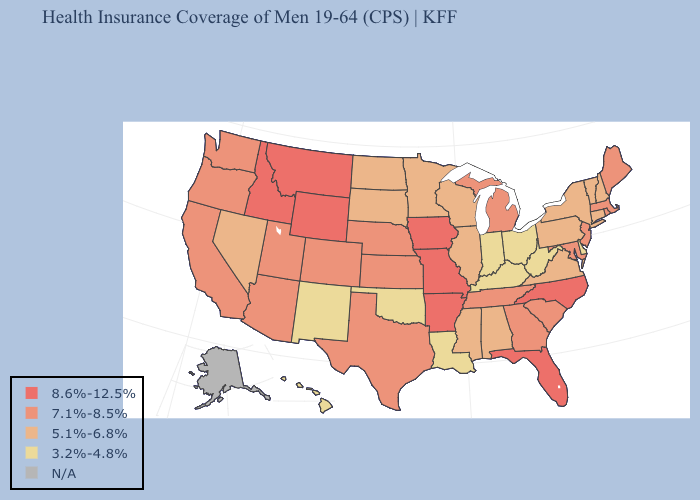What is the lowest value in the USA?
Concise answer only. 3.2%-4.8%. Name the states that have a value in the range 8.6%-12.5%?
Keep it brief. Arkansas, Florida, Idaho, Iowa, Missouri, Montana, North Carolina, Wyoming. Name the states that have a value in the range 3.2%-4.8%?
Keep it brief. Delaware, Hawaii, Indiana, Kentucky, Louisiana, New Mexico, Ohio, Oklahoma, West Virginia. What is the value of Maryland?
Concise answer only. 7.1%-8.5%. What is the value of North Carolina?
Short answer required. 8.6%-12.5%. What is the highest value in the USA?
Concise answer only. 8.6%-12.5%. Which states have the highest value in the USA?
Concise answer only. Arkansas, Florida, Idaho, Iowa, Missouri, Montana, North Carolina, Wyoming. Among the states that border Kansas , which have the lowest value?
Be succinct. Oklahoma. What is the value of Mississippi?
Be succinct. 5.1%-6.8%. Name the states that have a value in the range N/A?
Keep it brief. Alaska. What is the highest value in the USA?
Keep it brief. 8.6%-12.5%. Is the legend a continuous bar?
Short answer required. No. Does the first symbol in the legend represent the smallest category?
Answer briefly. No. Does Missouri have the highest value in the MidWest?
Short answer required. Yes. 